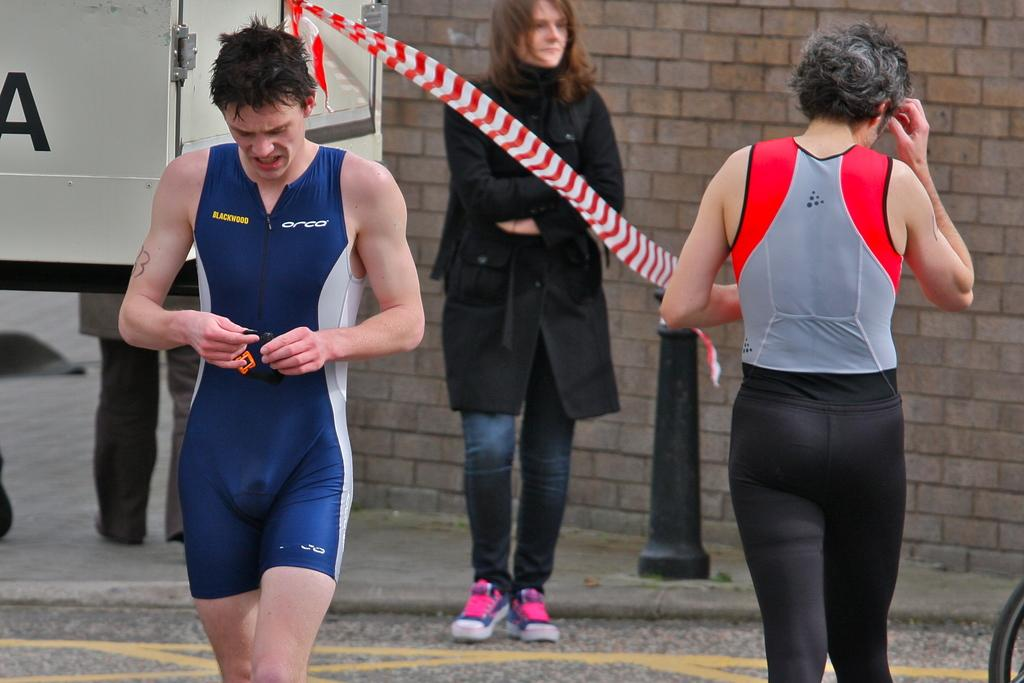<image>
Share a concise interpretation of the image provided. A guy wearing a blue outfit that says BLACKWOOD and ORCA on it. 